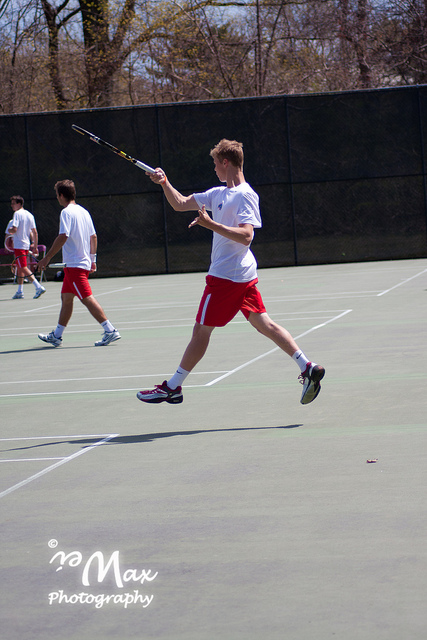Can you describe what the person in the foreground is doing? The person in the foreground is in an athletic stance, mid-action, likely hitting a tennis ball with a backhand swing. 